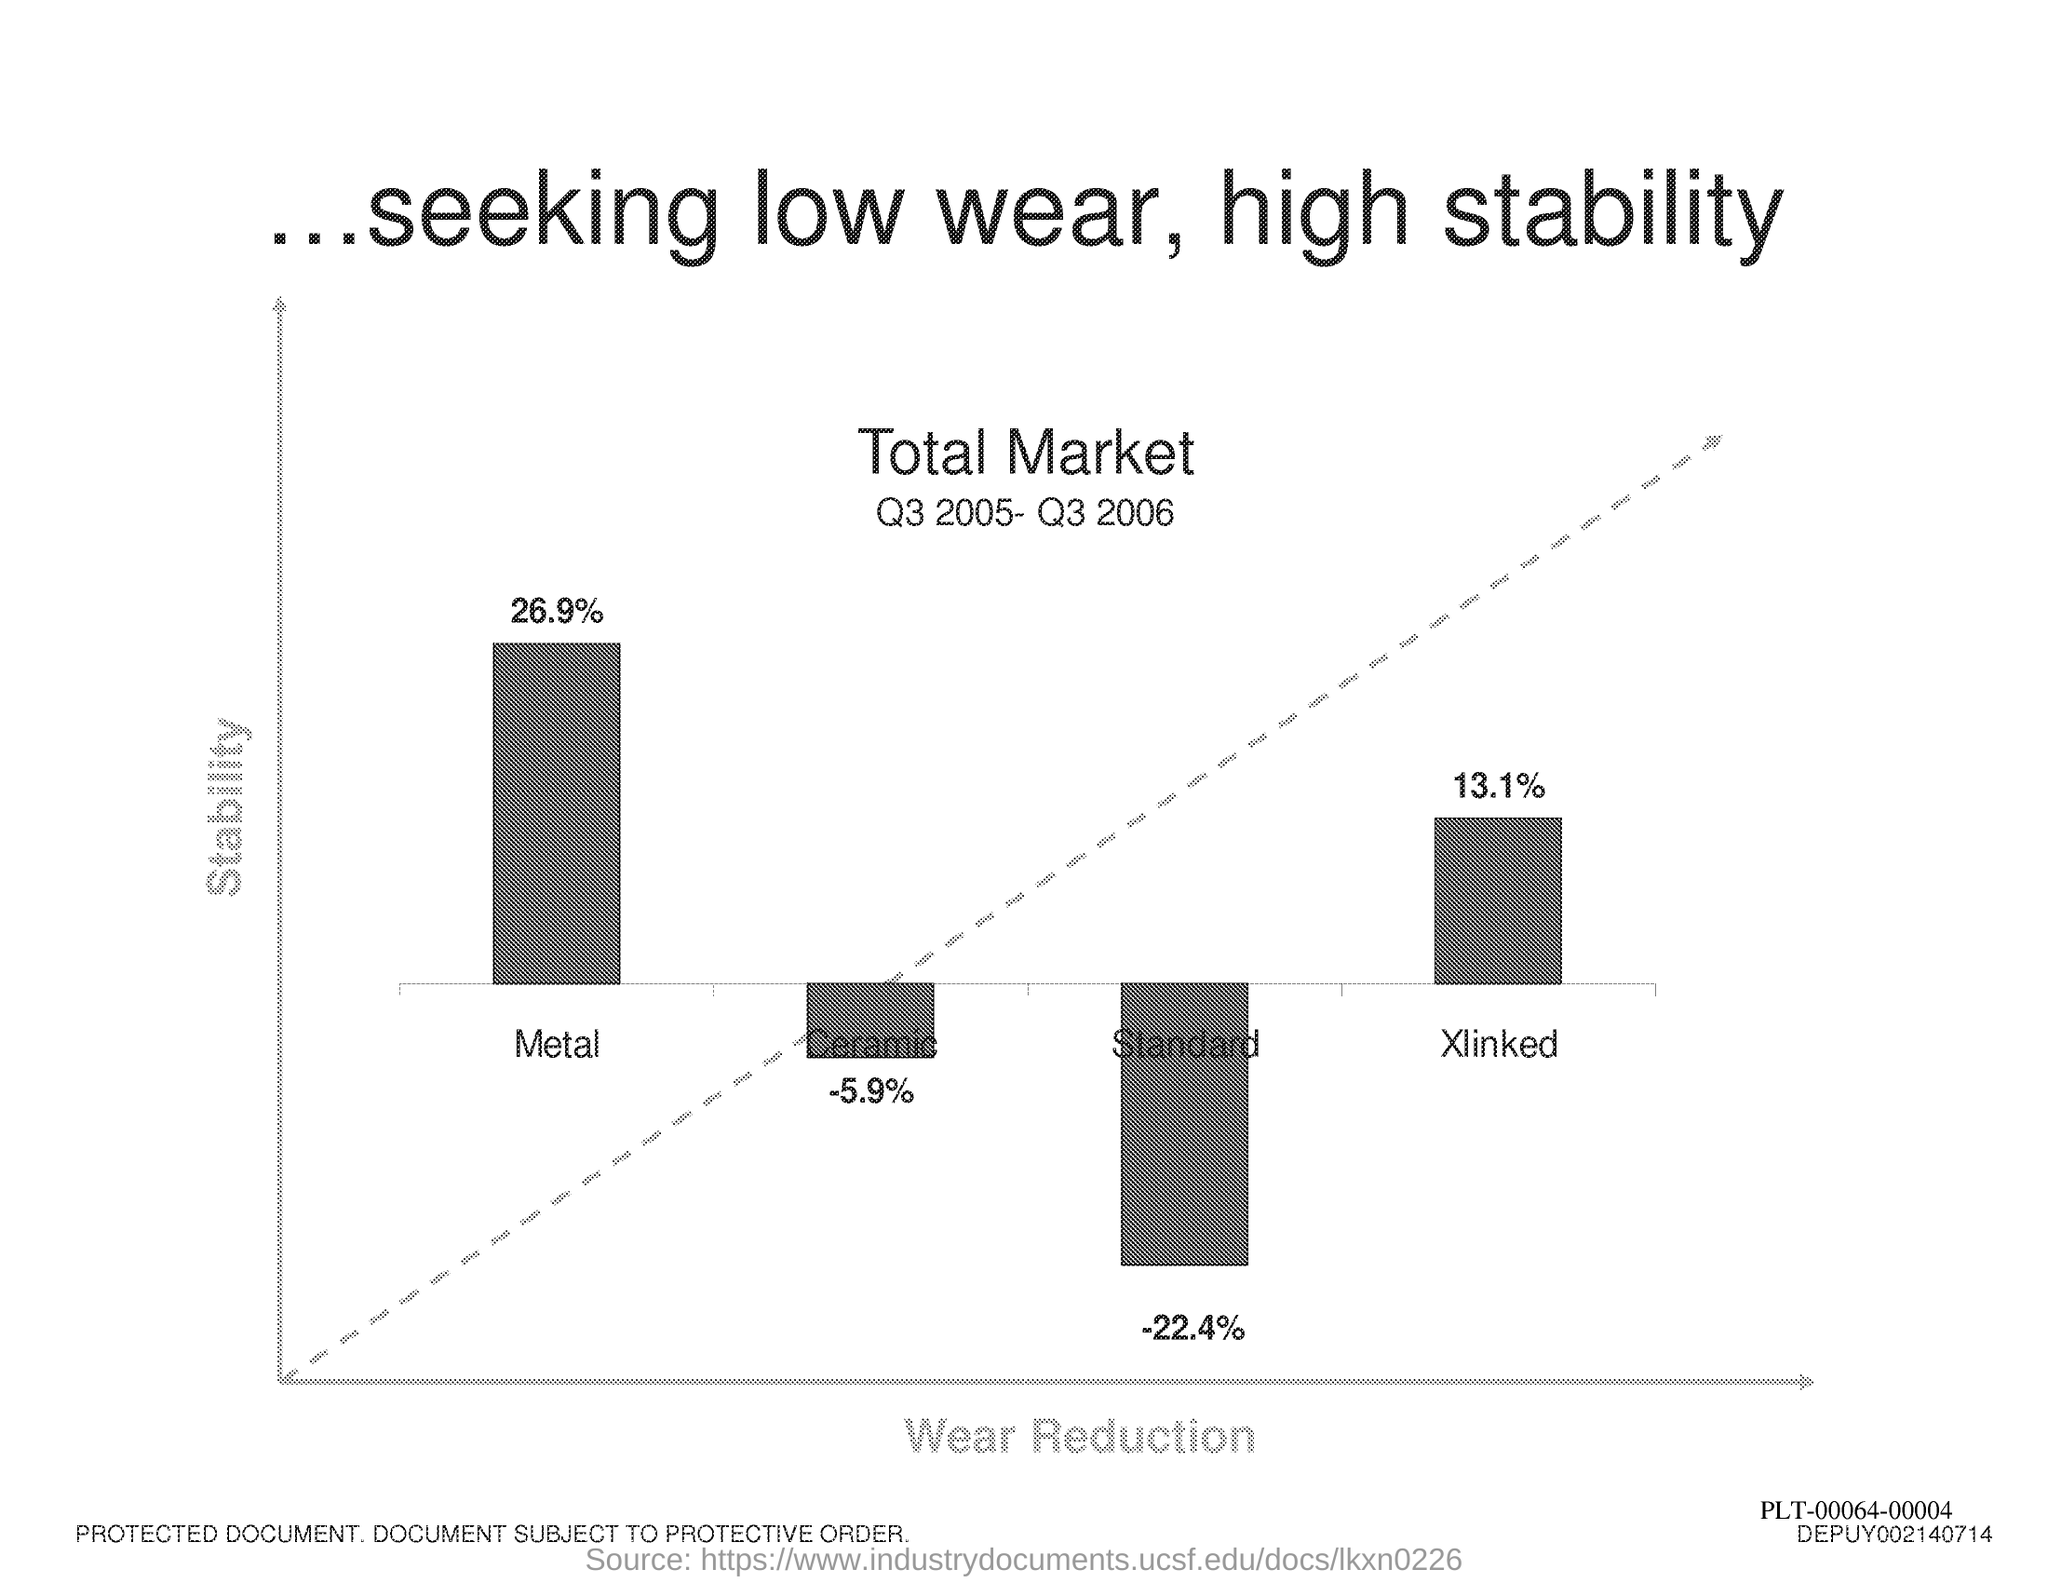What is plotted in the y-axis?
Keep it short and to the point. Stability. What is plotted in the x-axis ?
Offer a terse response. Wear Reduction. 